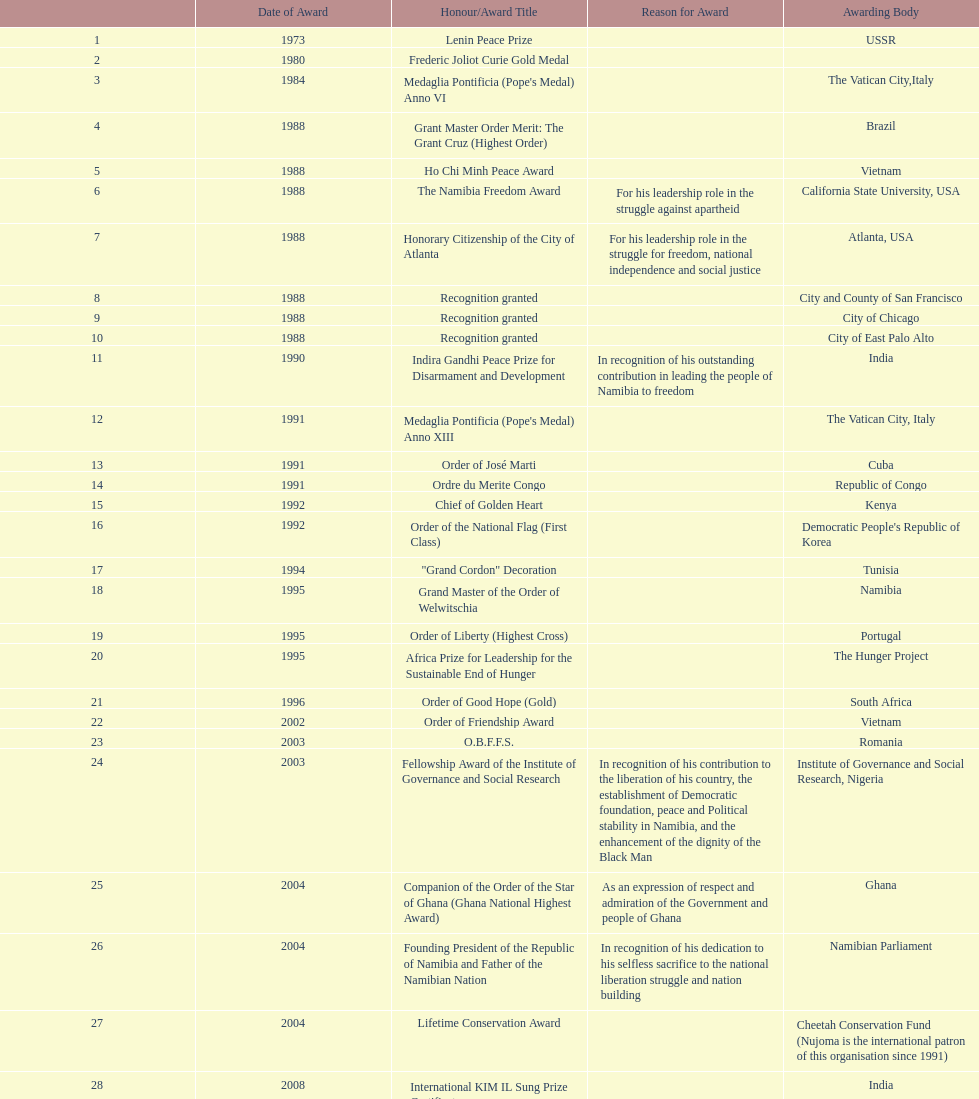What were the total number of honors/award titles listed according to this chart? 29. 